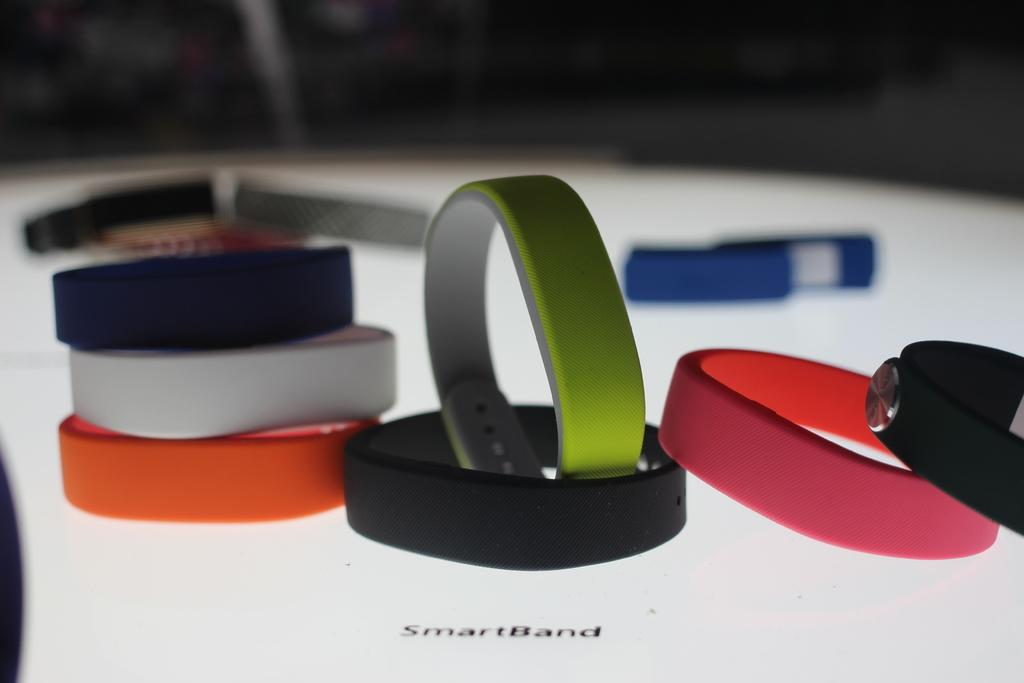What type of objects are displayed in the image? There are various colors of smart bands in the image. What is the surface on which the smart bands are placed? The smart bands are on a white surface. Can you describe the background of the image? The background of the image is blurred. Can you see any donkeys swimming in the lake in the image? There is no lake or donkey present in the image; it features various colors of smart bands on a white surface with a blurred background. 